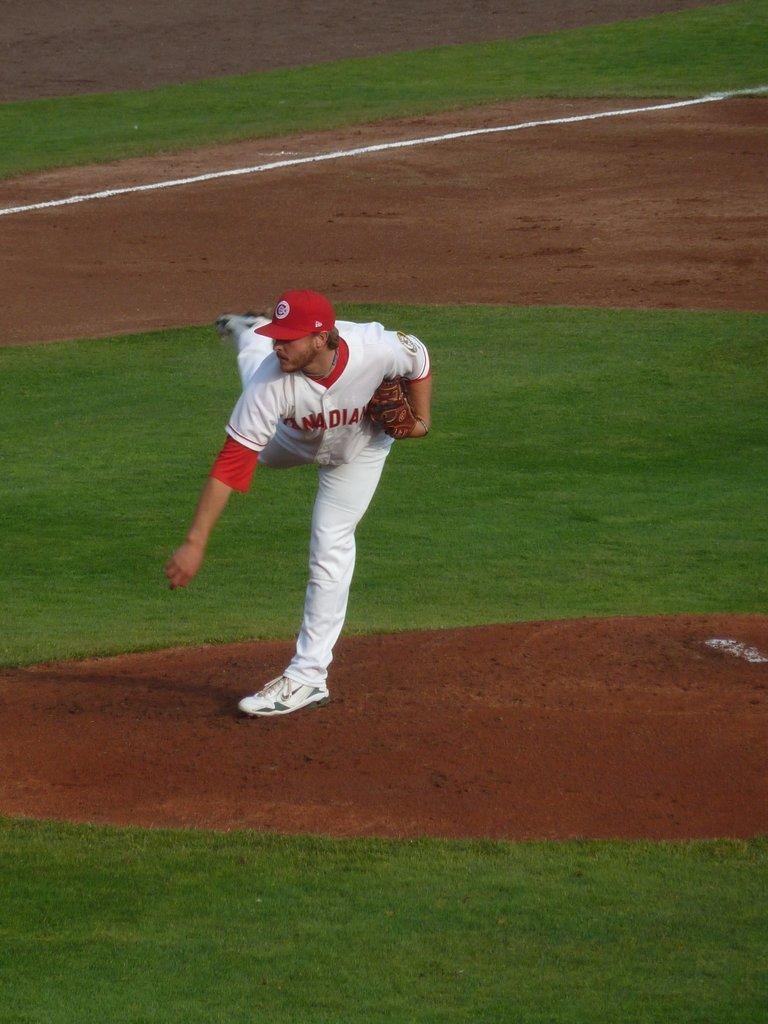<image>
Provide a brief description of the given image. a pitcher on the mound from team canadian 